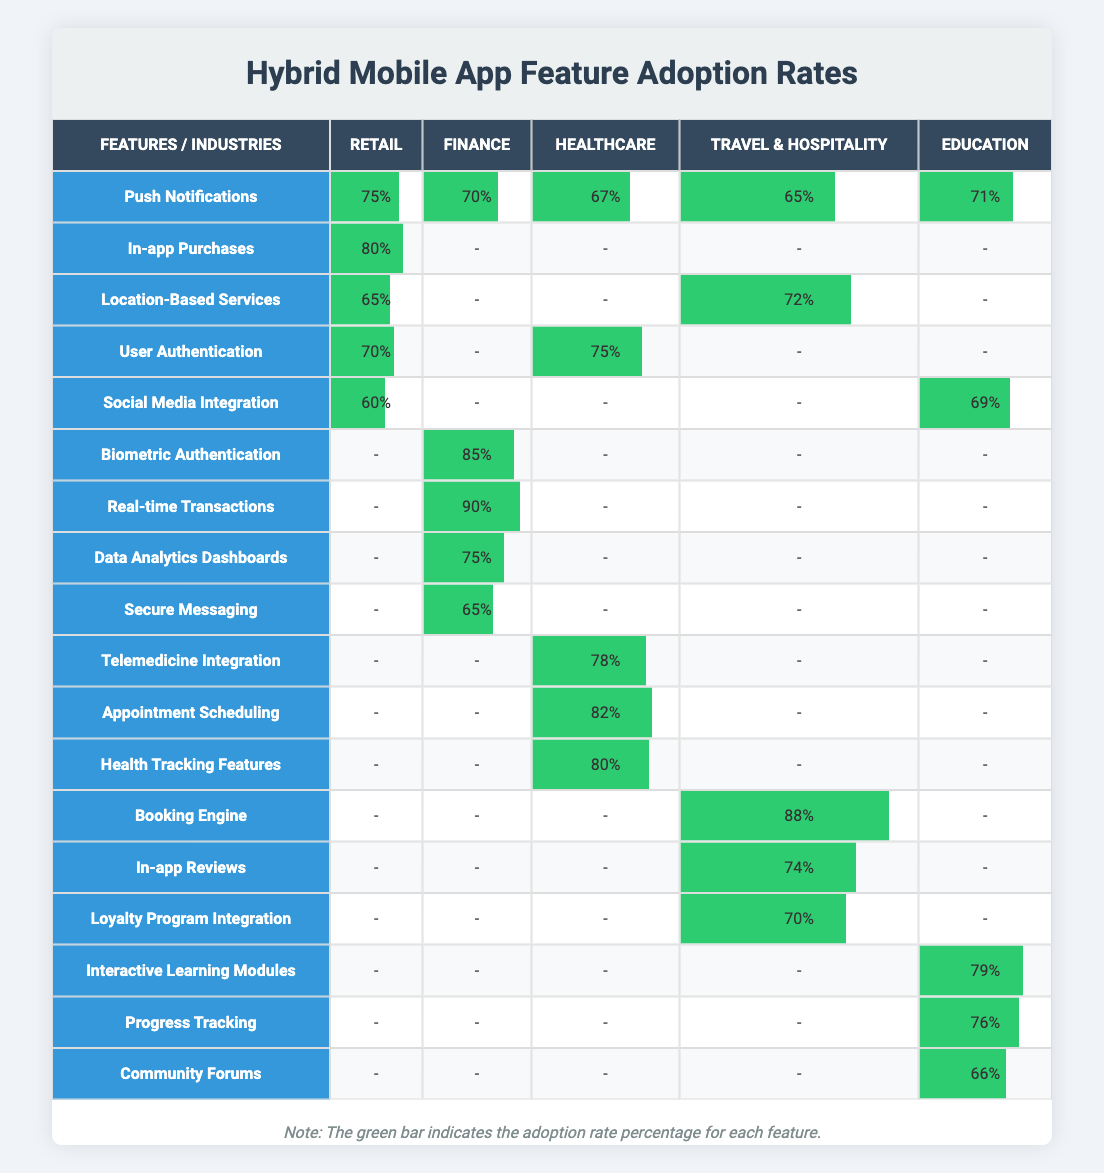What is the adoption rate for Push Notifications in the Finance industry? The table shows that for the feature Push Notifications, the adoption rate in the Finance industry is listed as 70%.
Answer: 70% Which industry has the highest adoption rate for Biometric Authentication? Looking at the row for Biometric Authentication, it is listed under the Finance industry with an adoption rate of 85%, which is the highest among the industries.
Answer: Finance What is the difference in adoption rates between In-app Purchases in Retail and Real-time Transactions in Finance? The adoption rate for In-app Purchases in Retail is 80%, while Real-time Transactions in Finance is 90%. The difference is calculated as 90% - 80% = 10%.
Answer: 10% What percentage of Healthcare apps adopted Health Tracking Features? According to the table, the adoption rate for Health Tracking Features in the Healthcare industry is reported as 80%.
Answer: 80% Do any industries have the same adoption rate for Social Media Integration? Upon reviewing the table, Social Media Integration shows an adoption rate of 69% in the Education industry and 60% in Retail, which are different. Therefore, no industries have the same adoption rate for this feature.
Answer: No Which feature shows the greatest variability in adoption rates across all industries? Analyzing the table, Push Notifications show adoption rates of 75% (Retail), 70% (Finance), 67% (Healthcare), 65% (Travel & Hospitality), and 71% (Education). The minimum is 65% and the maximum is 75%, resulting in variability of 10%. Other features show less range.
Answer: Push Notifications How many industries have an adoption rate above 70% for Location-Based Services? By examining the table, the adoption rate for Location-Based Services is 65% (Retail) and 72% (Travel & Hospitality). Only one industry (Travel & Hospitality) exceeds 70%.
Answer: 1 What features have been adopted in more than three industries? By checking the table, features like Push Notifications (5 industries), and User Authentication (3 industries) fit this criterion. The most adopted is Push Notifications, in all industries.
Answer: Push Notifications What is the average adoption rate of Interactive Learning Modules in the education sector? Since Interactive Learning Modules specifically pertain to the Education industry with an adoption rate of 79%, the average is simply that value because it pertains to a single industry.
Answer: 79 